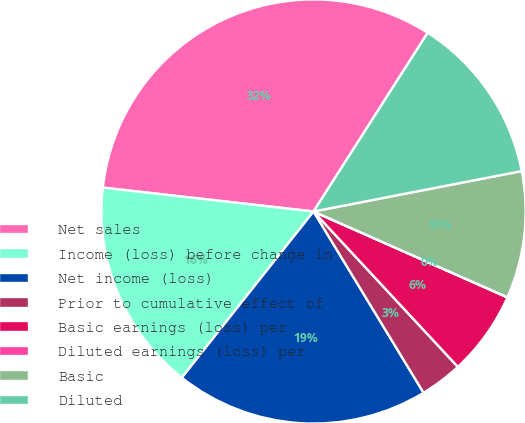<chart> <loc_0><loc_0><loc_500><loc_500><pie_chart><fcel>Net sales<fcel>Income (loss) before change in<fcel>Net income (loss)<fcel>Prior to cumulative effect of<fcel>Basic earnings (loss) per<fcel>Diluted earnings (loss) per<fcel>Basic<fcel>Diluted<nl><fcel>32.25%<fcel>16.13%<fcel>19.35%<fcel>3.23%<fcel>6.45%<fcel>0.01%<fcel>9.68%<fcel>12.9%<nl></chart> 